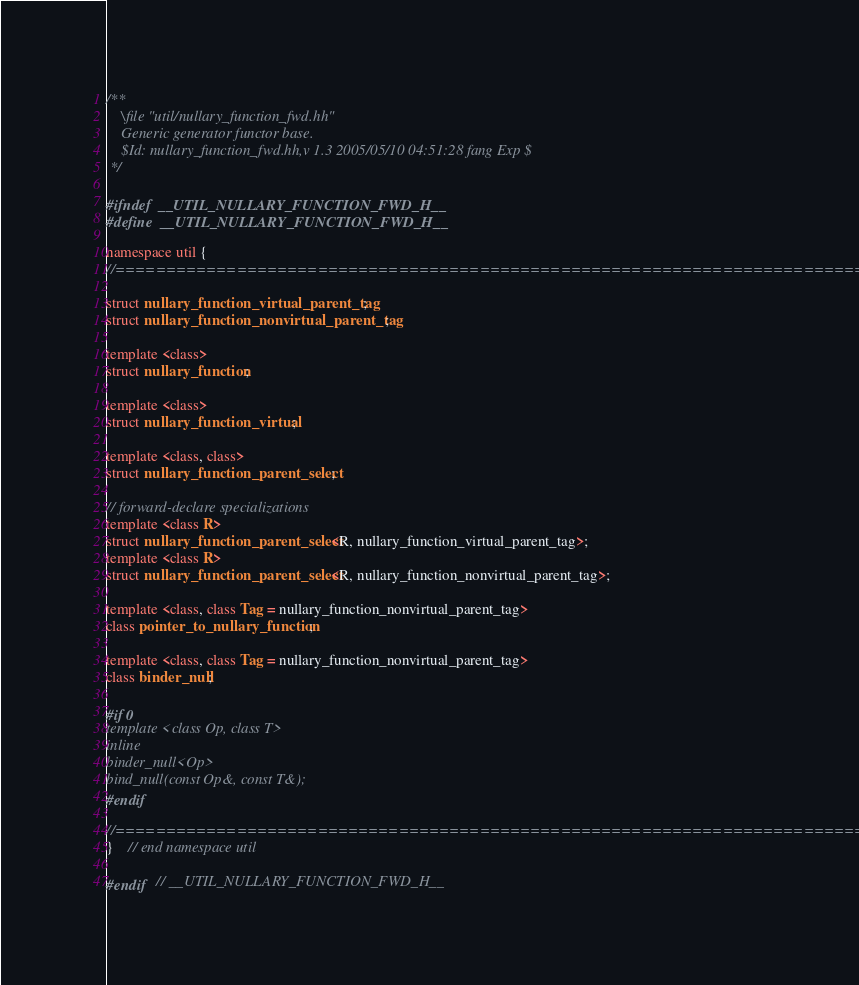Convert code to text. <code><loc_0><loc_0><loc_500><loc_500><_C++_>/**
	\file "util/nullary_function_fwd.hh"
	Generic generator functor base.
	$Id: nullary_function_fwd.hh,v 1.3 2005/05/10 04:51:28 fang Exp $
 */

#ifndef	__UTIL_NULLARY_FUNCTION_FWD_H__
#define	__UTIL_NULLARY_FUNCTION_FWD_H__

namespace util {
//=============================================================================

struct nullary_function_virtual_parent_tag;
struct nullary_function_nonvirtual_parent_tag;

template <class>
struct nullary_function;

template <class>
struct nullary_function_virtual;

template <class, class>
struct nullary_function_parent_select;

// forward-declare specializations
template <class R>
struct nullary_function_parent_select<R, nullary_function_virtual_parent_tag>;
template <class R>
struct nullary_function_parent_select<R, nullary_function_nonvirtual_parent_tag>;

template <class, class Tag = nullary_function_nonvirtual_parent_tag>
class pointer_to_nullary_function;

template <class, class Tag = nullary_function_nonvirtual_parent_tag>
class binder_null;

#if 0
template <class Op, class T>
inline
binder_null<Op>
bind_null(const Op&, const T&);
#endif

//=============================================================================
}	// end namespace util

#endif	// __UTIL_NULLARY_FUNCTION_FWD_H__

</code> 